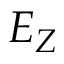Convert formula to latex. <formula><loc_0><loc_0><loc_500><loc_500>E _ { Z }</formula> 